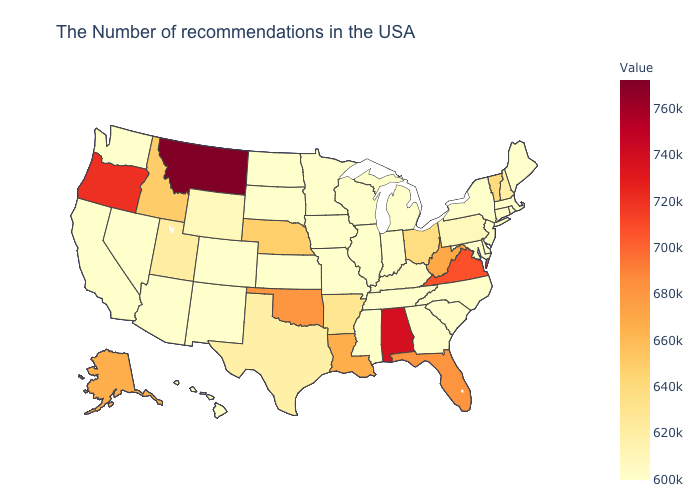Among the states that border Massachusetts , which have the lowest value?
Concise answer only. Rhode Island, New York. Does Oregon have a higher value than Wisconsin?
Answer briefly. Yes. Does Montana have the lowest value in the USA?
Concise answer only. No. Does Tennessee have a higher value than Vermont?
Give a very brief answer. No. Among the states that border Kansas , which have the highest value?
Give a very brief answer. Oklahoma. Among the states that border South Dakota , which have the highest value?
Answer briefly. Montana. 